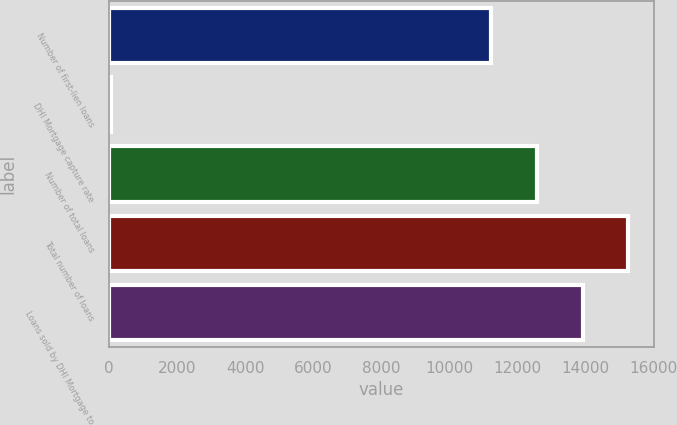Convert chart. <chart><loc_0><loc_0><loc_500><loc_500><bar_chart><fcel>Number of first-lien loans<fcel>DHI Mortgage capture rate<fcel>Number of total loans<fcel>Total number of loans<fcel>Loans sold by DHI Mortgage to<nl><fcel>11228<fcel>59<fcel>12572<fcel>15260<fcel>13916<nl></chart> 